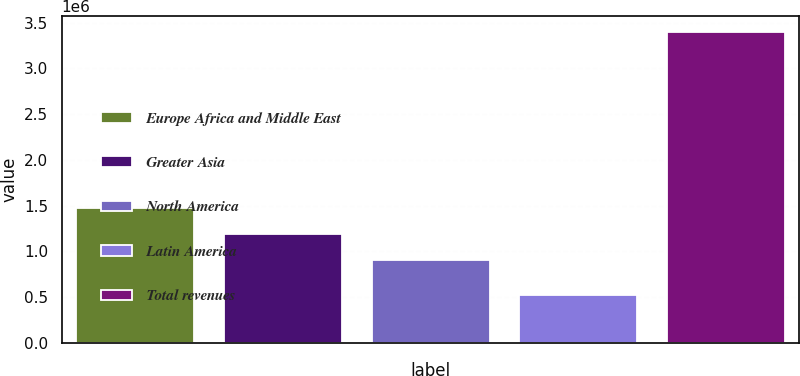Convert chart to OTSL. <chart><loc_0><loc_0><loc_500><loc_500><bar_chart><fcel>Europe Africa and Middle East<fcel>Greater Asia<fcel>North America<fcel>Latin America<fcel>Total revenues<nl><fcel>1.47601e+06<fcel>1.18892e+06<fcel>901821<fcel>527756<fcel>3.39872e+06<nl></chart> 